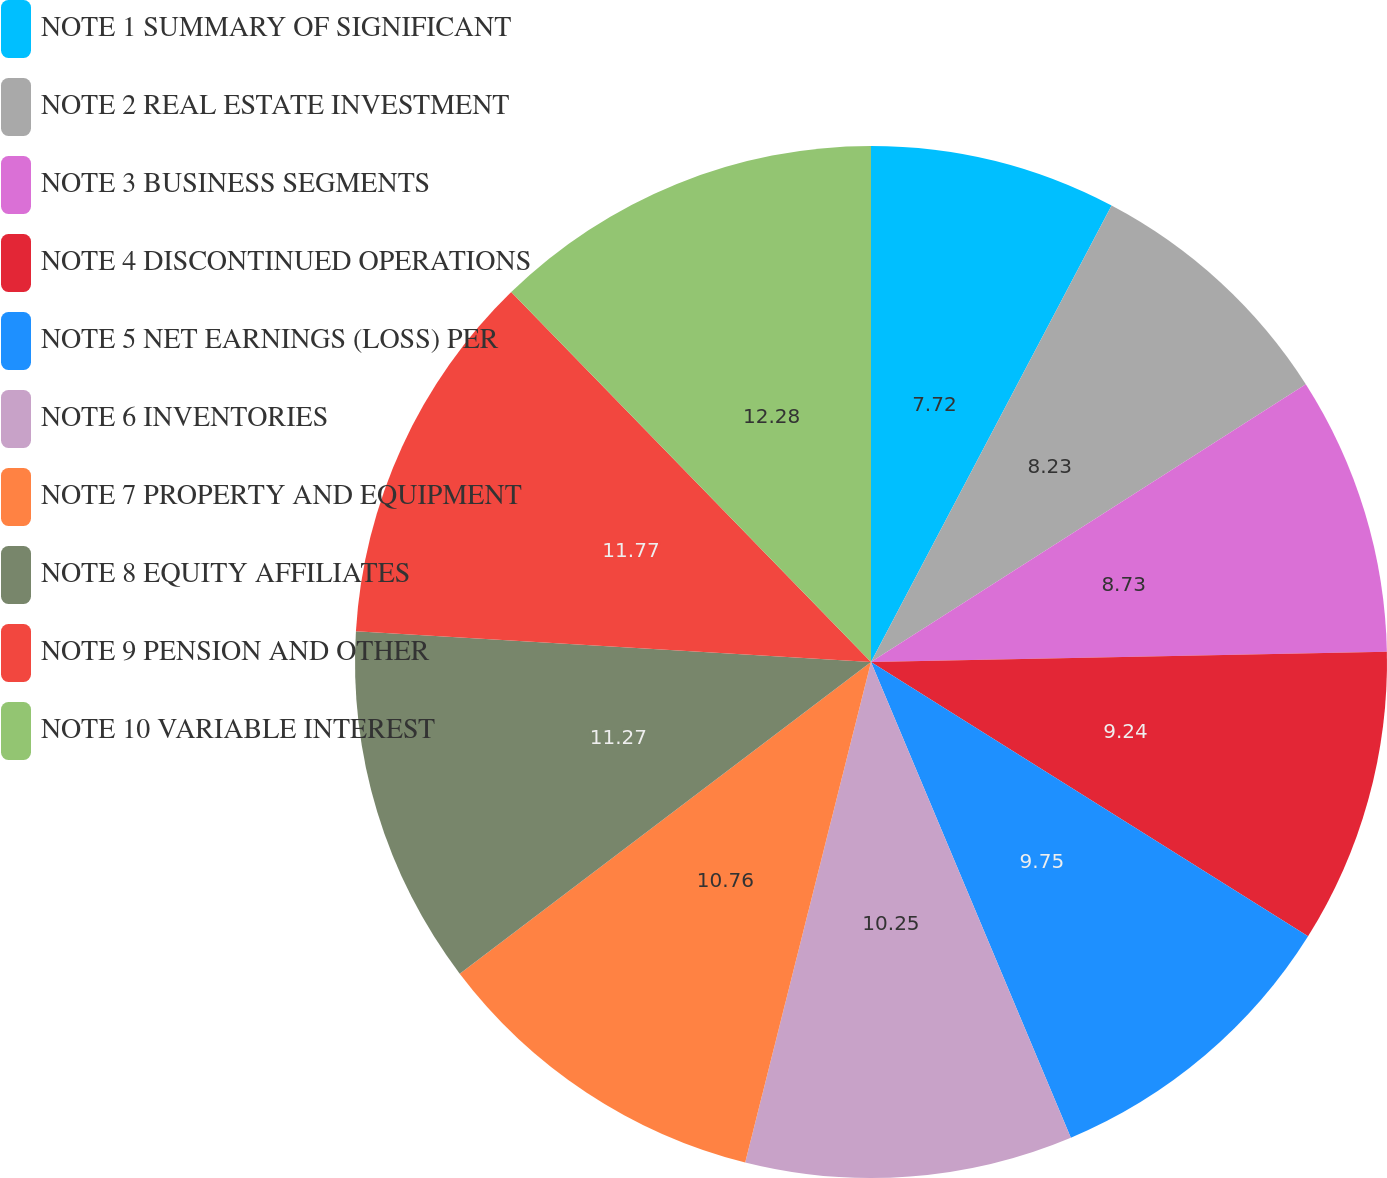Convert chart to OTSL. <chart><loc_0><loc_0><loc_500><loc_500><pie_chart><fcel>NOTE 1 SUMMARY OF SIGNIFICANT<fcel>NOTE 2 REAL ESTATE INVESTMENT<fcel>NOTE 3 BUSINESS SEGMENTS<fcel>NOTE 4 DISCONTINUED OPERATIONS<fcel>NOTE 5 NET EARNINGS (LOSS) PER<fcel>NOTE 6 INVENTORIES<fcel>NOTE 7 PROPERTY AND EQUIPMENT<fcel>NOTE 8 EQUITY AFFILIATES<fcel>NOTE 9 PENSION AND OTHER<fcel>NOTE 10 VARIABLE INTEREST<nl><fcel>7.72%<fcel>8.23%<fcel>8.73%<fcel>9.24%<fcel>9.75%<fcel>10.25%<fcel>10.76%<fcel>11.27%<fcel>11.77%<fcel>12.28%<nl></chart> 